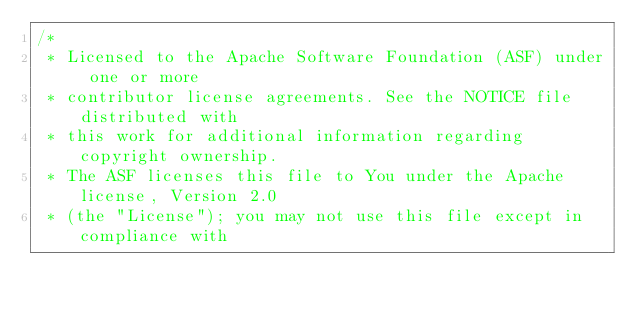<code> <loc_0><loc_0><loc_500><loc_500><_Java_>/*
 * Licensed to the Apache Software Foundation (ASF) under one or more
 * contributor license agreements. See the NOTICE file distributed with
 * this work for additional information regarding copyright ownership.
 * The ASF licenses this file to You under the Apache license, Version 2.0
 * (the "License"); you may not use this file except in compliance with</code> 